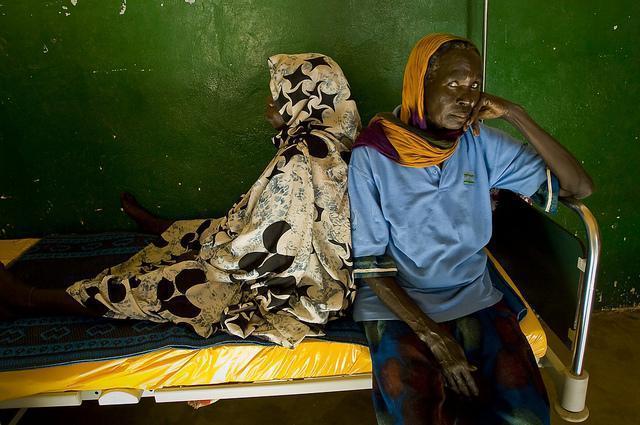How many people are there?
Give a very brief answer. 2. 